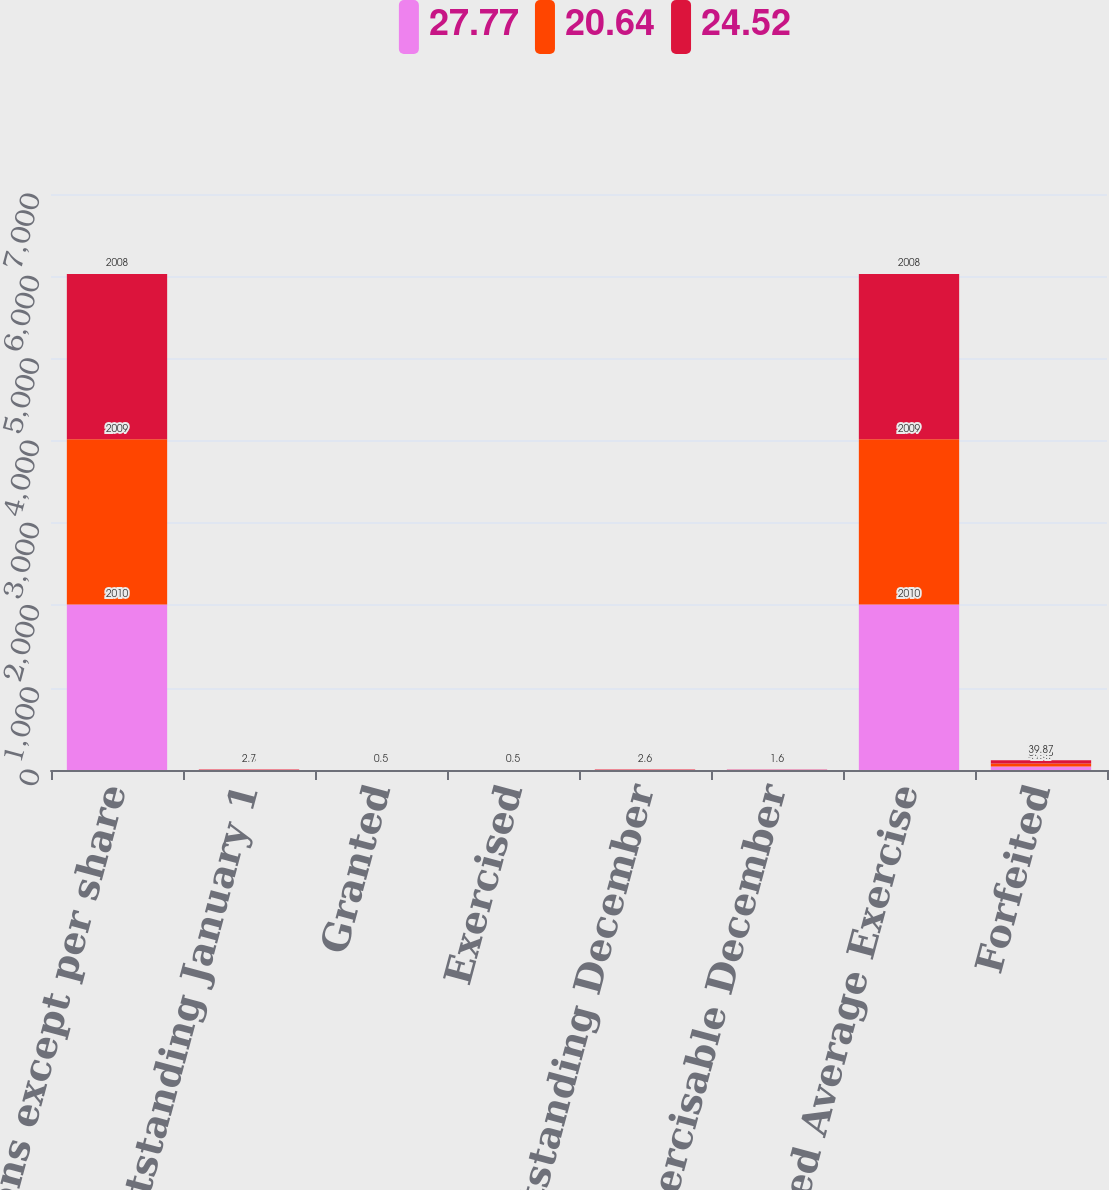Convert chart. <chart><loc_0><loc_0><loc_500><loc_500><stacked_bar_chart><ecel><fcel>(in millions except per share<fcel>Options outstanding January 1<fcel>Granted<fcel>Exercised<fcel>Options outstanding December<fcel>Options exercisable December<fcel>Weighted Average Exercise<fcel>Forfeited<nl><fcel>27.77<fcel>2010<fcel>2.7<fcel>0.6<fcel>0.3<fcel>2.9<fcel>1.8<fcel>2010<fcel>41.47<nl><fcel>20.64<fcel>2009<fcel>2.6<fcel>0.4<fcel>0.3<fcel>2.7<fcel>1.7<fcel>2009<fcel>37.43<nl><fcel>24.52<fcel>2008<fcel>2.7<fcel>0.5<fcel>0.5<fcel>2.6<fcel>1.6<fcel>2008<fcel>39.87<nl></chart> 